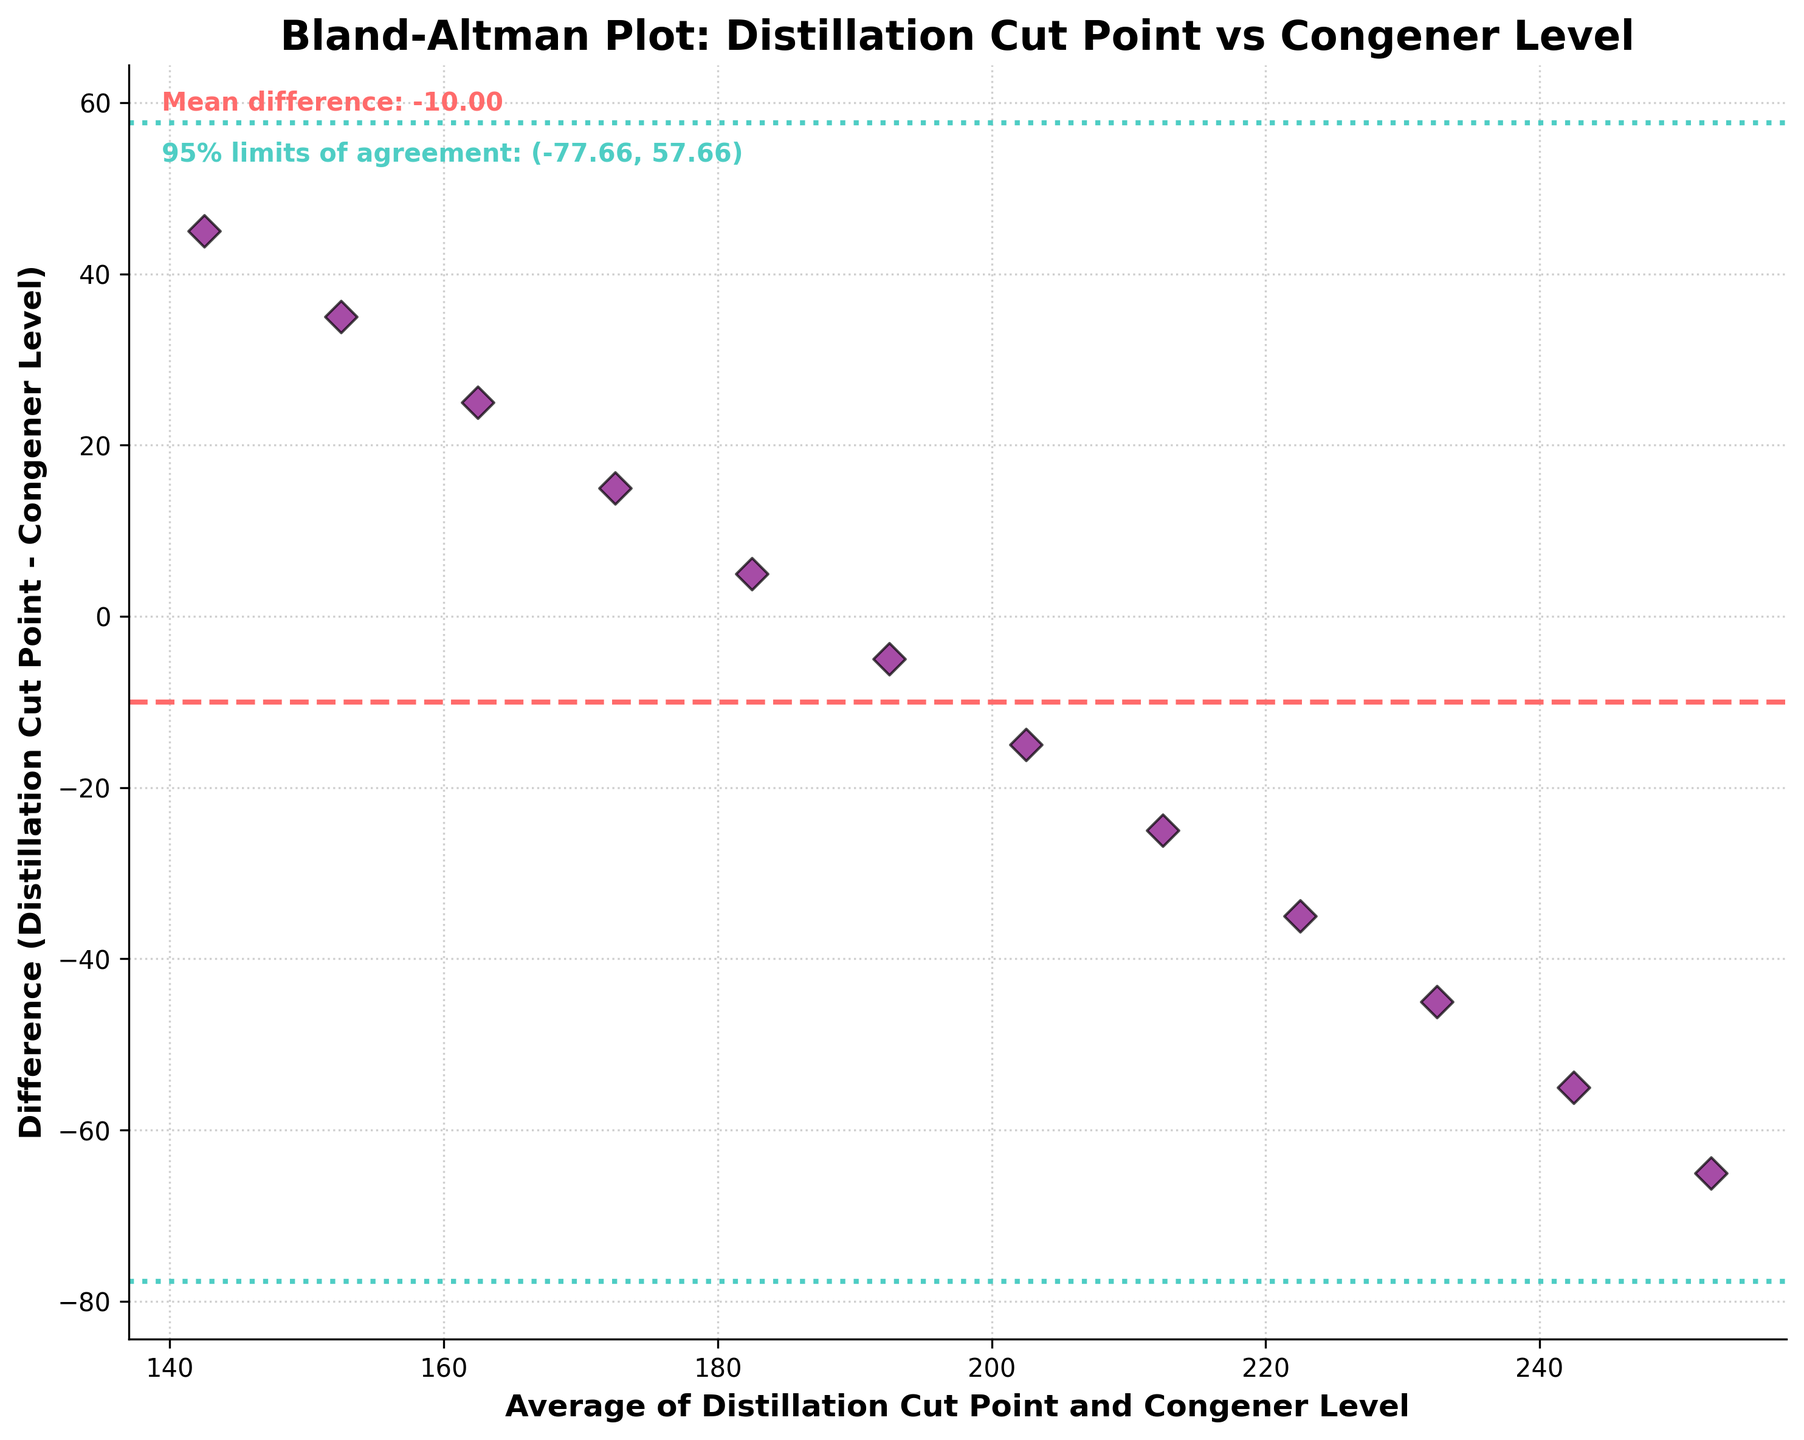What is the title of the figure? The title of a figure is usually written at the top of the plot. In this case, it clearly states the comparison and what variables are being discussed.
Answer: Bland-Altman Plot: Distillation Cut Point vs Congener Level What do the colors of the horizontal lines represent? The colors of the horizontal lines help distinguish the mean difference and the 95% limits of agreement. The dotted lines in teal represent the 95% limits, and the dashed line in red represents the mean difference.
Answer: Red dashed line is the mean difference, teal dotted lines are the 95% limits of agreement How many data points are plotted in this figure? To determine this, count all the dots on the scatter plot. Each dot represents one data point.
Answer: 12 Is the mean difference positive or negative? The mean difference can be determined by the positioning of the dashed line relative to the horizontal axis. Since the dashed line is above the horizontal axis, the mean difference is positive.
Answer: Positive What is the value of the mean difference? This information is mentioned near the top of the plot with a specific value provided. The text states that the mean difference is a certain number.
Answer: 42.5 What are the values of the 95% limits of agreement? The values for the 95% limits are provided in the annotations near the top of the plot. These limits usually lie symmetrically around the mean difference.
Answer: (13.69, 71.31) What does each dot in the scatter plot represent? Each dot represents a specific pairing of data points. In this plot, dots show the average of the distillation cut point and congener level on the x-axis, and the difference between the distillation cut point and congener level on the y-axis.
Answer: An average vs. difference pairing of distillation cut point and congener level Is there a general trend visible among the data points in the Bland-Altman plot? In Bland-Altman plots, a visible trend among the data points would indicate a relationship between the difference and the magnitude of measurements. There does not appear to be a specific increasing or decreasing trend across the scatter plot.
Answer: No How wide is the range between the 95% limits of agreement? The range is computed by subtracting the lower limit from the upper limit of the 95% limits.
Answer: 71.31 - 13.69 = 57.62 Are any points outside the limits of agreement? This can be seen by checking if any points lie outside the teal dotted lines which indicate the 95% limits of agreement.
Answer: No 